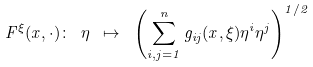Convert formula to latex. <formula><loc_0><loc_0><loc_500><loc_500>F ^ { \xi } ( x , \cdot ) \colon \ \eta \ \mapsto \ \left ( \sum _ { i , j = 1 } ^ { n } g _ { i j } ( x , \xi ) \eta ^ { i } \eta ^ { j } \right ) ^ { 1 / 2 }</formula> 